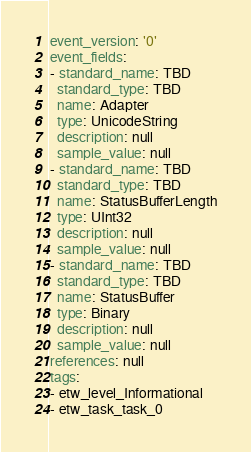<code> <loc_0><loc_0><loc_500><loc_500><_YAML_>event_version: '0'
event_fields:
- standard_name: TBD
  standard_type: TBD
  name: Adapter
  type: UnicodeString
  description: null
  sample_value: null
- standard_name: TBD
  standard_type: TBD
  name: StatusBufferLength
  type: UInt32
  description: null
  sample_value: null
- standard_name: TBD
  standard_type: TBD
  name: StatusBuffer
  type: Binary
  description: null
  sample_value: null
references: null
tags:
- etw_level_Informational
- etw_task_task_0
</code> 